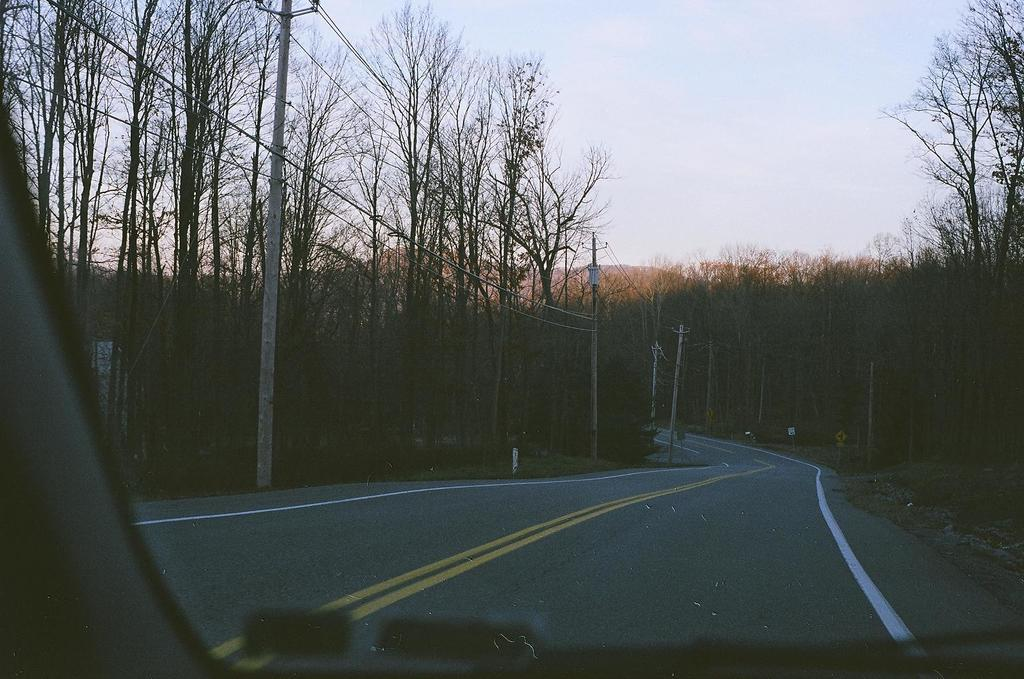What is the main feature of the image? There is a road in the image. What can be seen alongside the road? There are poles and wires on the side of the road. What type of vegetation is present in the image? There are trees in the image. What is moving along the road? There is a vehicle in the image. What can be seen in the distance in the image? There are hills visible in the background of the image, and the sky is also visible. Where are the books being stored in the image? There are no books present in the image. What type of wound can be seen on the tree in the image? There are no wounds visible on the trees in the image. 